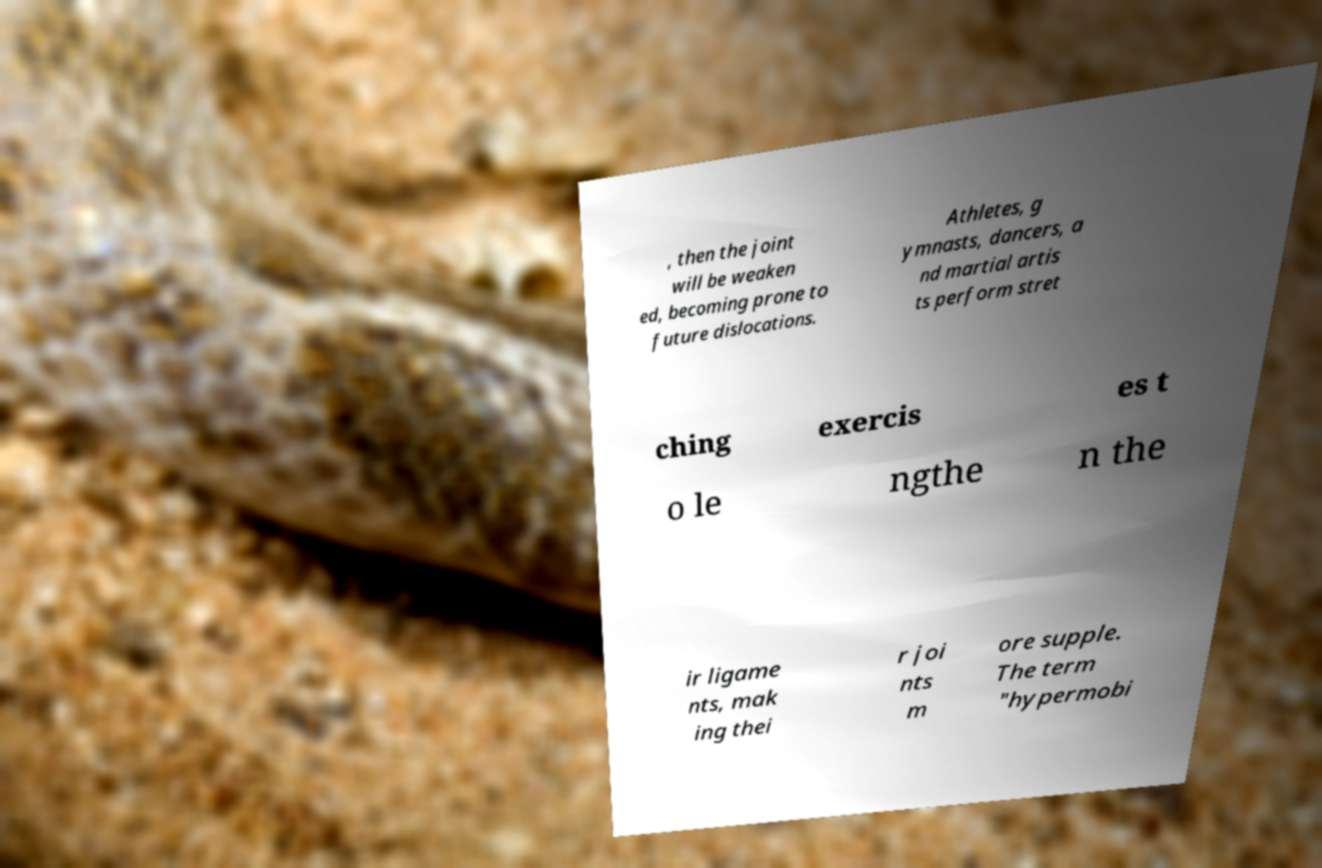There's text embedded in this image that I need extracted. Can you transcribe it verbatim? , then the joint will be weaken ed, becoming prone to future dislocations. Athletes, g ymnasts, dancers, a nd martial artis ts perform stret ching exercis es t o le ngthe n the ir ligame nts, mak ing thei r joi nts m ore supple. The term "hypermobi 